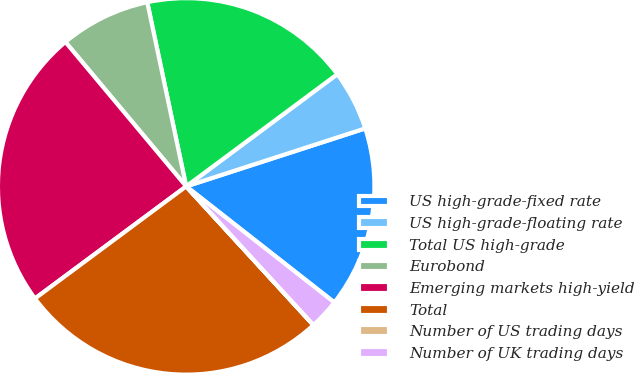Convert chart. <chart><loc_0><loc_0><loc_500><loc_500><pie_chart><fcel>US high-grade-fixed rate<fcel>US high-grade-floating rate<fcel>Total US high-grade<fcel>Eurobond<fcel>Emerging markets high-yield<fcel>Total<fcel>Number of US trading days<fcel>Number of UK trading days<nl><fcel>15.56%<fcel>5.18%<fcel>18.15%<fcel>7.77%<fcel>24.07%<fcel>26.66%<fcel>0.01%<fcel>2.6%<nl></chart> 